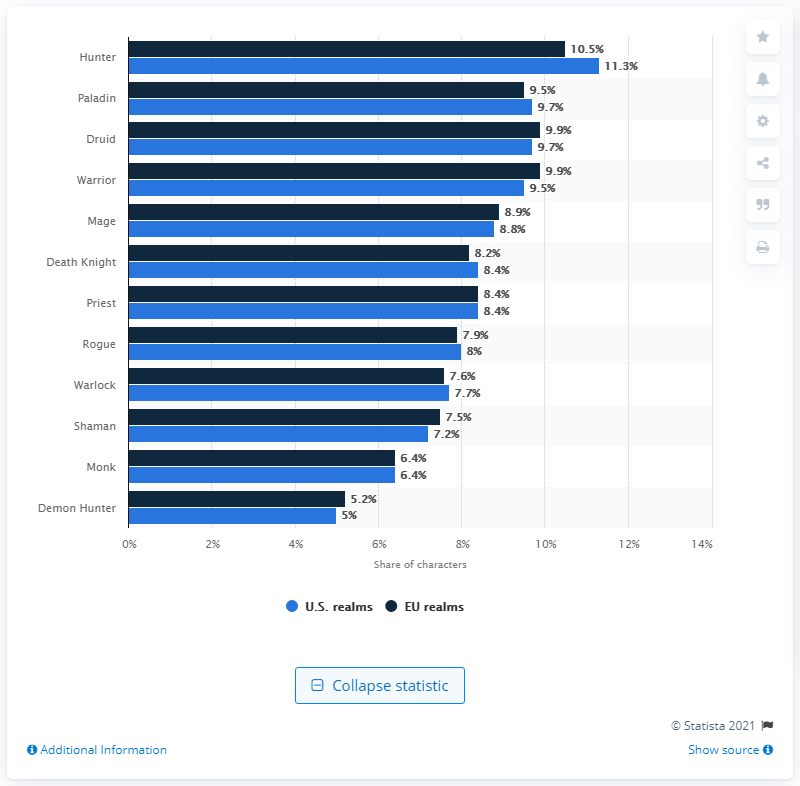Mention a couple of crucial points in this snapshot. In the United States, approximately 9.5% of all characters created were warriors. 